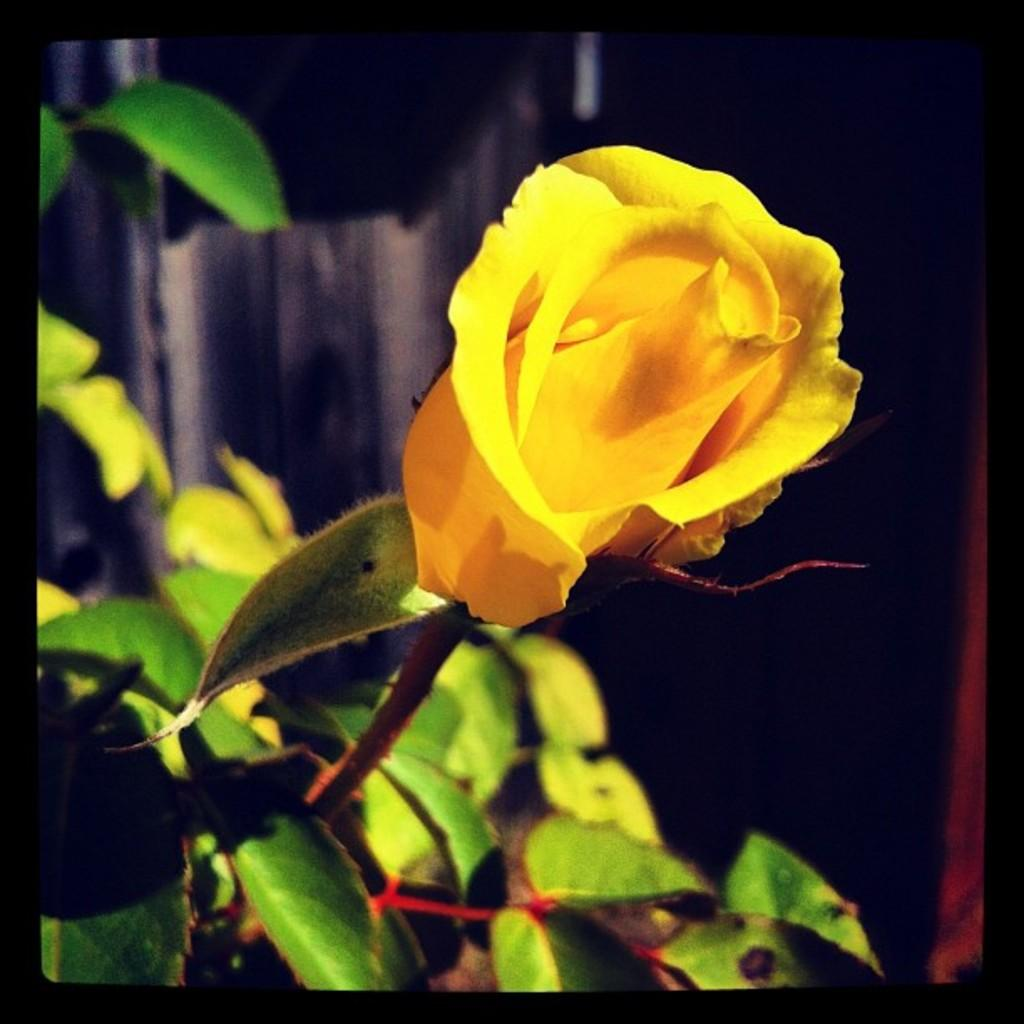What type of flower is in the image? There is a yellow rose flower in the image. Where is the flower located? The yellow rose flower is present on a plant. What type of board can be seen supporting the flower in the image? There is no board present in the image; the flower is on a plant. What is the smell of the flower in the image? The image does not provide information about the smell of the flower, as it is a visual representation. 